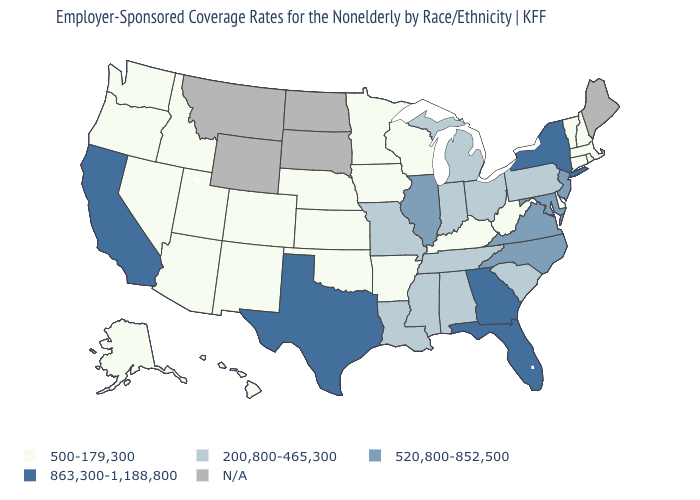Does Vermont have the lowest value in the Northeast?
Keep it brief. Yes. What is the value of Hawaii?
Quick response, please. 500-179,300. What is the value of California?
Short answer required. 863,300-1,188,800. How many symbols are there in the legend?
Quick response, please. 5. How many symbols are there in the legend?
Concise answer only. 5. What is the highest value in states that border Utah?
Give a very brief answer. 500-179,300. What is the lowest value in states that border Arkansas?
Quick response, please. 500-179,300. What is the value of Indiana?
Be succinct. 200,800-465,300. Name the states that have a value in the range 520,800-852,500?
Answer briefly. Illinois, Maryland, New Jersey, North Carolina, Virginia. Name the states that have a value in the range 200,800-465,300?
Keep it brief. Alabama, Indiana, Louisiana, Michigan, Mississippi, Missouri, Ohio, Pennsylvania, South Carolina, Tennessee. Name the states that have a value in the range N/A?
Write a very short answer. Maine, Montana, North Dakota, South Dakota, Wyoming. What is the lowest value in the USA?
Give a very brief answer. 500-179,300. What is the value of New York?
Write a very short answer. 863,300-1,188,800. Among the states that border Wisconsin , which have the highest value?
Quick response, please. Illinois. 